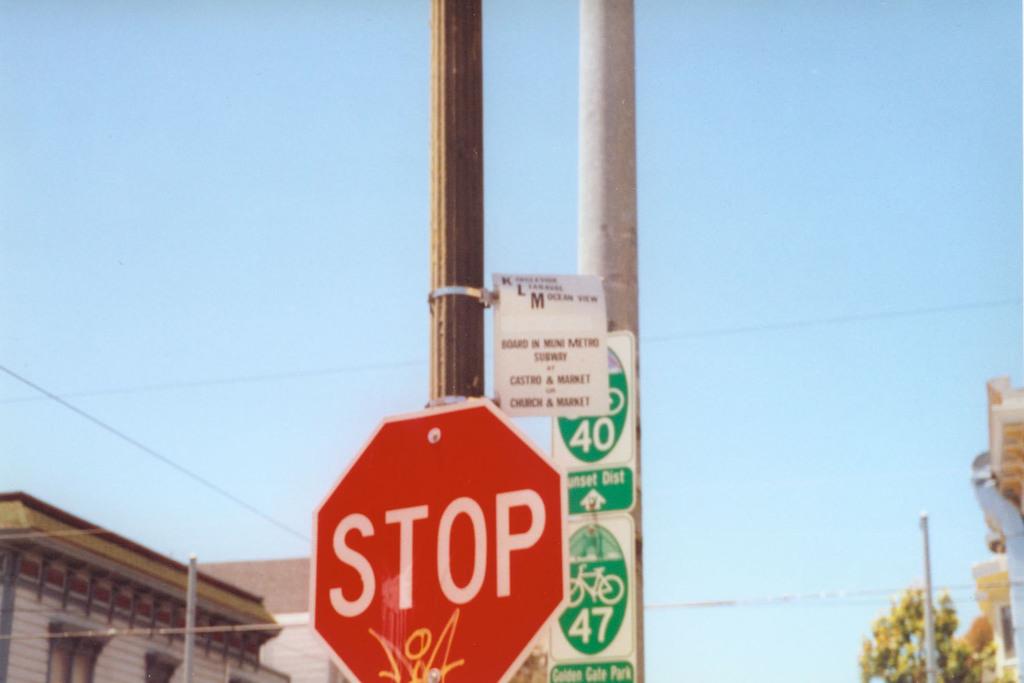What is the word in white?
Offer a very short reply. Stop. What two bike lanes are up ahead?
Offer a terse response. 40 and 47. 